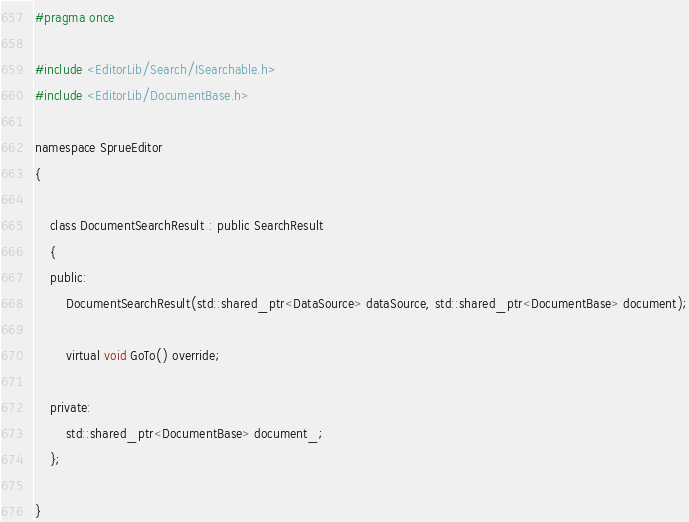<code> <loc_0><loc_0><loc_500><loc_500><_C_>#pragma once

#include <EditorLib/Search/ISearchable.h>
#include <EditorLib/DocumentBase.h>

namespace SprueEditor
{

    class DocumentSearchResult : public SearchResult
    {
    public:
        DocumentSearchResult(std::shared_ptr<DataSource> dataSource, std::shared_ptr<DocumentBase> document);

        virtual void GoTo() override;

    private:
        std::shared_ptr<DocumentBase> document_;
    };

}</code> 